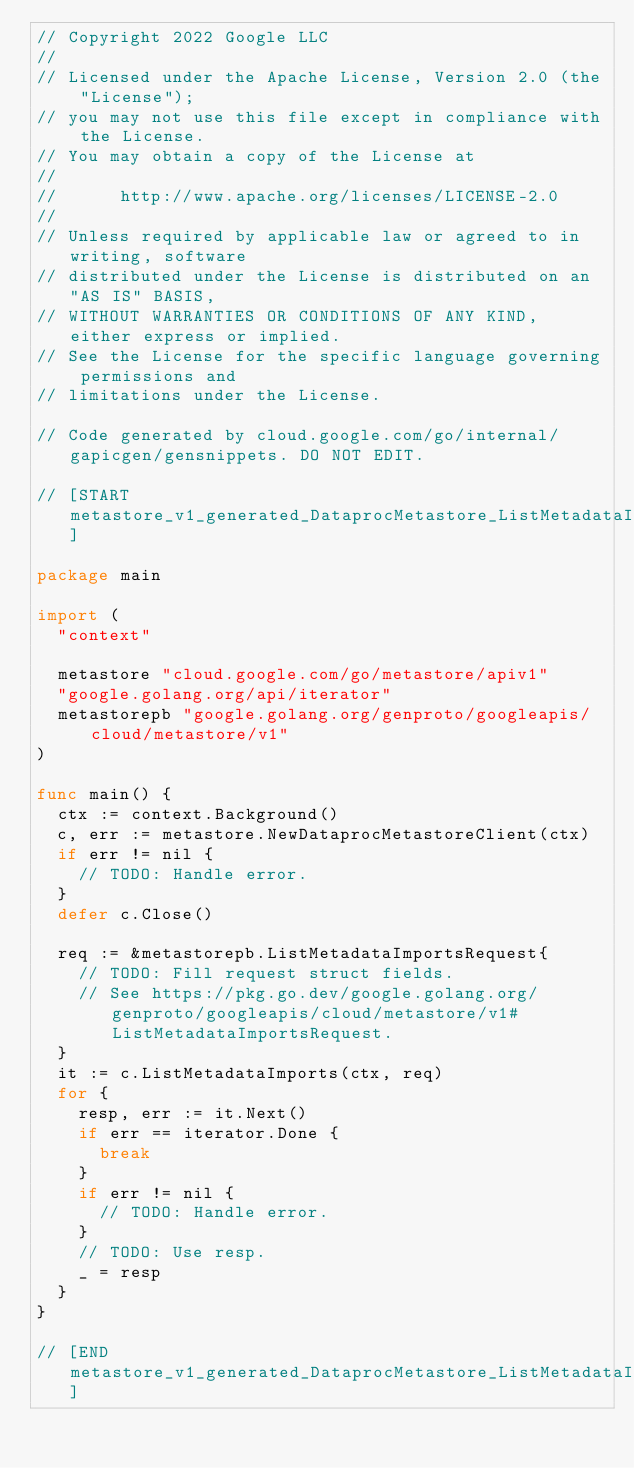Convert code to text. <code><loc_0><loc_0><loc_500><loc_500><_Go_>// Copyright 2022 Google LLC
//
// Licensed under the Apache License, Version 2.0 (the "License");
// you may not use this file except in compliance with the License.
// You may obtain a copy of the License at
//
//      http://www.apache.org/licenses/LICENSE-2.0
//
// Unless required by applicable law or agreed to in writing, software
// distributed under the License is distributed on an "AS IS" BASIS,
// WITHOUT WARRANTIES OR CONDITIONS OF ANY KIND, either express or implied.
// See the License for the specific language governing permissions and
// limitations under the License.

// Code generated by cloud.google.com/go/internal/gapicgen/gensnippets. DO NOT EDIT.

// [START metastore_v1_generated_DataprocMetastore_ListMetadataImports_sync]

package main

import (
	"context"

	metastore "cloud.google.com/go/metastore/apiv1"
	"google.golang.org/api/iterator"
	metastorepb "google.golang.org/genproto/googleapis/cloud/metastore/v1"
)

func main() {
	ctx := context.Background()
	c, err := metastore.NewDataprocMetastoreClient(ctx)
	if err != nil {
		// TODO: Handle error.
	}
	defer c.Close()

	req := &metastorepb.ListMetadataImportsRequest{
		// TODO: Fill request struct fields.
		// See https://pkg.go.dev/google.golang.org/genproto/googleapis/cloud/metastore/v1#ListMetadataImportsRequest.
	}
	it := c.ListMetadataImports(ctx, req)
	for {
		resp, err := it.Next()
		if err == iterator.Done {
			break
		}
		if err != nil {
			// TODO: Handle error.
		}
		// TODO: Use resp.
		_ = resp
	}
}

// [END metastore_v1_generated_DataprocMetastore_ListMetadataImports_sync]
</code> 